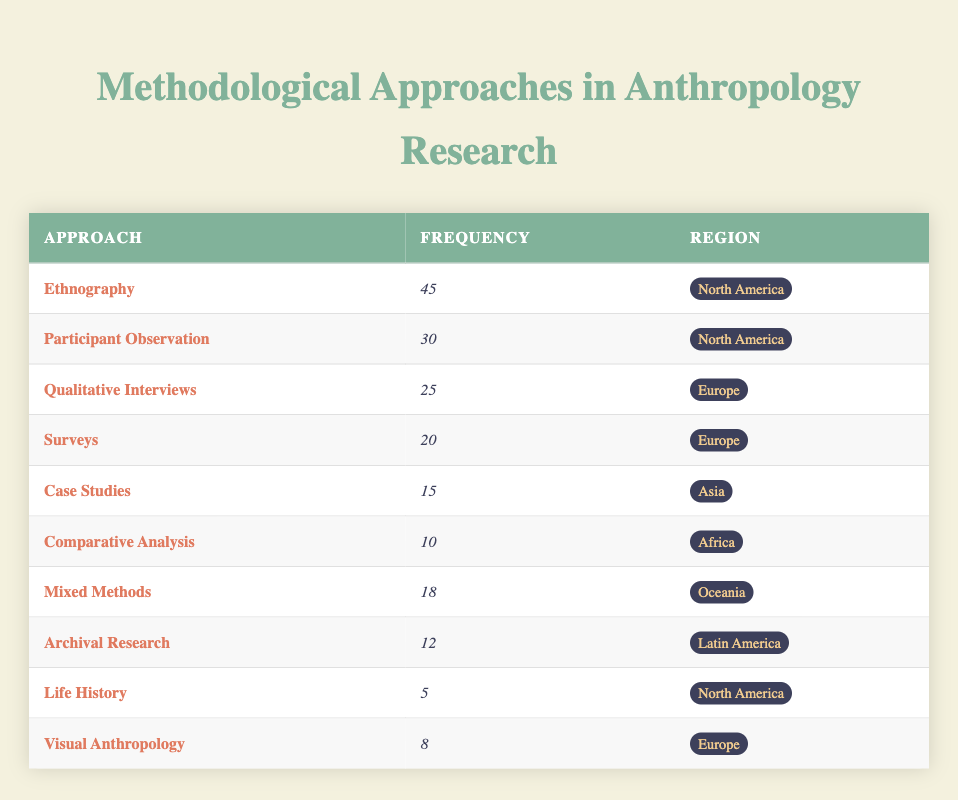What is the most frequently used methodological approach in North America? The table indicates that the highest frequency of any approach in North America is 45, corresponding to Ethnography.
Answer: Ethnography How many times is Participant Observation used in North America? The frequency of Participant Observation in North America is directly provided in the table as 30.
Answer: 30 Which region has the lowest frequency of methodological approaches listed? After analyzing the frequencies, Africa has the lowest frequency with 10 for Comparative Analysis.
Answer: Africa What is the sum of frequencies for qualitative approaches (Qualitative Interviews and Participant Observation) in Europe? Qualitative Interviews have a frequency of 25 and Participant Observation has a frequency of 20. Summing these gives 25 + 20 = 45.
Answer: 45 Does Life History have a higher frequency than Case Studies? The table shows that Life History has a frequency of 5, while Case Studies have a frequency of 15. Since 5 is not greater than 15, the statement is false.
Answer: No What is the difference in frequency between Ethnography and Mixed Methods? Ethnography has a frequency of 45, and Mixed Methods has a frequency of 18. The difference is calculated as 45 - 18 = 27.
Answer: 27 Which methodological approach is used in Europe with the second highest frequency? From the table, the two highest frequencies in Europe are 25 for Qualitative Interviews and 20 for Surveys. Therefore, Surveys have the second highest frequency.
Answer: Surveys Is there any approach listed in Oceania? Yes, the table shows that Mixed Methods is listed under Oceania with a frequency of 18.
Answer: Yes What is the average frequency of methodological approaches used in Latin America and Oceania? In Latin America, Archival Research has a frequency of 12 and in Oceania, Mixed Methods has a frequency of 18. The average is calculated as (12 + 18) / 2 = 15.
Answer: 15 